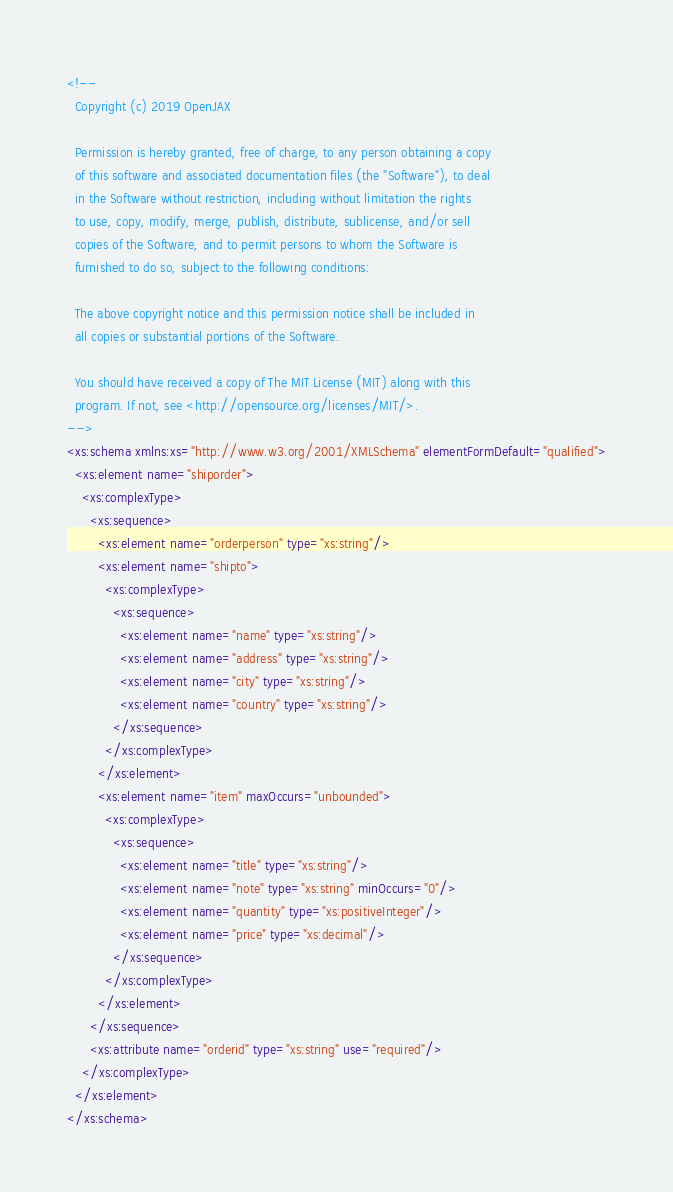<code> <loc_0><loc_0><loc_500><loc_500><_XML_><!--
  Copyright (c) 2019 OpenJAX

  Permission is hereby granted, free of charge, to any person obtaining a copy
  of this software and associated documentation files (the "Software"), to deal
  in the Software without restriction, including without limitation the rights
  to use, copy, modify, merge, publish, distribute, sublicense, and/or sell
  copies of the Software, and to permit persons to whom the Software is
  furnished to do so, subject to the following conditions:

  The above copyright notice and this permission notice shall be included in
  all copies or substantial portions of the Software.

  You should have received a copy of The MIT License (MIT) along with this
  program. If not, see <http://opensource.org/licenses/MIT/>.
-->
<xs:schema xmlns:xs="http://www.w3.org/2001/XMLSchema" elementFormDefault="qualified">
  <xs:element name="shiporder">
    <xs:complexType>
      <xs:sequence>
        <xs:element name="orderperson" type="xs:string"/>
        <xs:element name="shipto">
          <xs:complexType>
            <xs:sequence>
              <xs:element name="name" type="xs:string"/>
              <xs:element name="address" type="xs:string"/>
              <xs:element name="city" type="xs:string"/>
              <xs:element name="country" type="xs:string"/>
            </xs:sequence>
          </xs:complexType>
        </xs:element>
        <xs:element name="item" maxOccurs="unbounded">
          <xs:complexType>
            <xs:sequence>
              <xs:element name="title" type="xs:string"/>
              <xs:element name="note" type="xs:string" minOccurs="0"/>
              <xs:element name="quantity" type="xs:positiveInteger"/>
              <xs:element name="price" type="xs:decimal"/>
            </xs:sequence>
          </xs:complexType>
        </xs:element>
      </xs:sequence>
      <xs:attribute name="orderid" type="xs:string" use="required"/>
    </xs:complexType>
  </xs:element>
</xs:schema></code> 